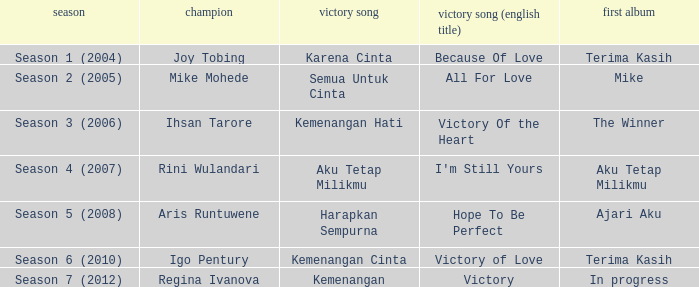Which English winning song had the winner aris runtuwene? Hope To Be Perfect. 